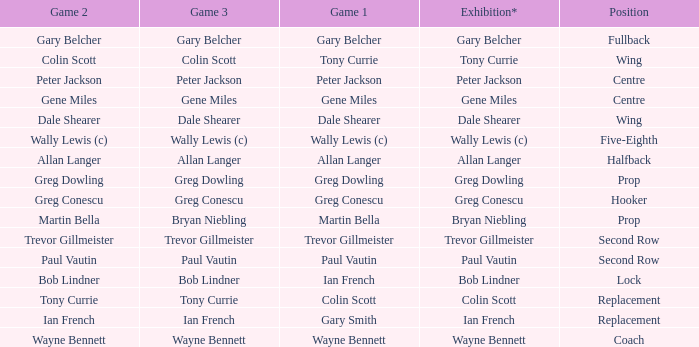Wjat game 3 has ian french as a game of 2? Ian French. 